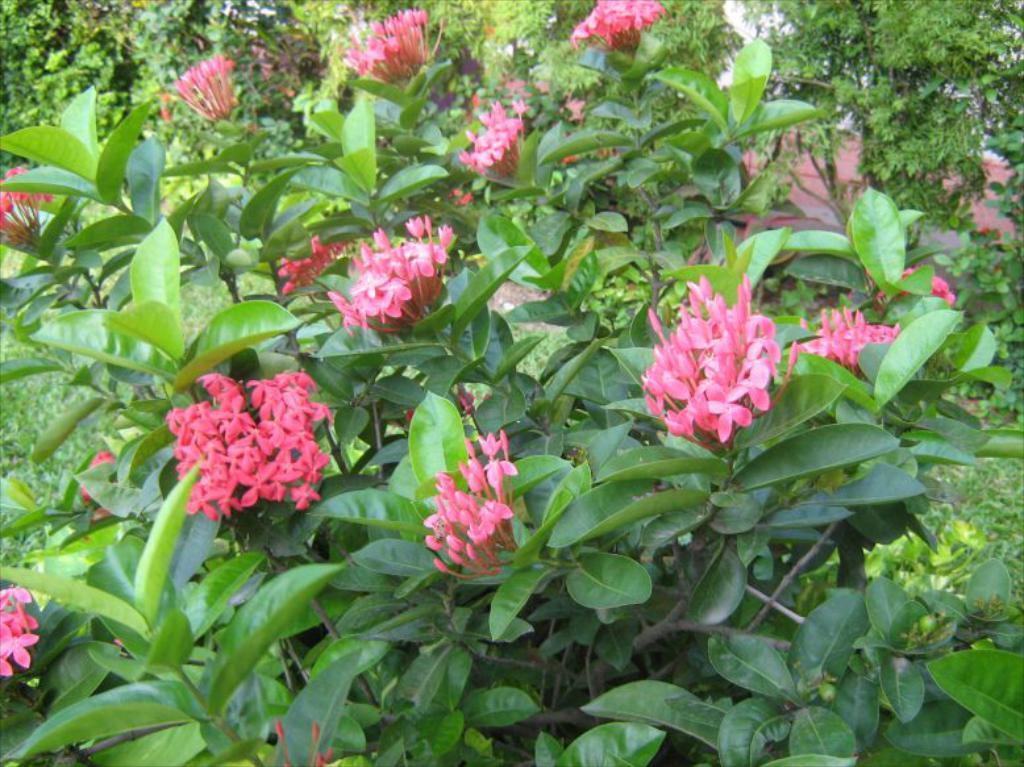What is present on the plants in the image? There are flowers on the plants in the image. What else can be seen at the bottom of the plants? There are leaves at the bottom of the plants in the image. What structure is located on the right side of the image? There is a shed on the right side of the image. What other natural elements are present on the right side of the image? There are trees, plants, and grass on the right side of the image. What type of yam is being used to decorate the shed in the image? There is no yam present in the image, and therefore no such decoration can be observed. What color is the silver decoration on the plants in the image? There is no silver decoration present on the plants in the image. 